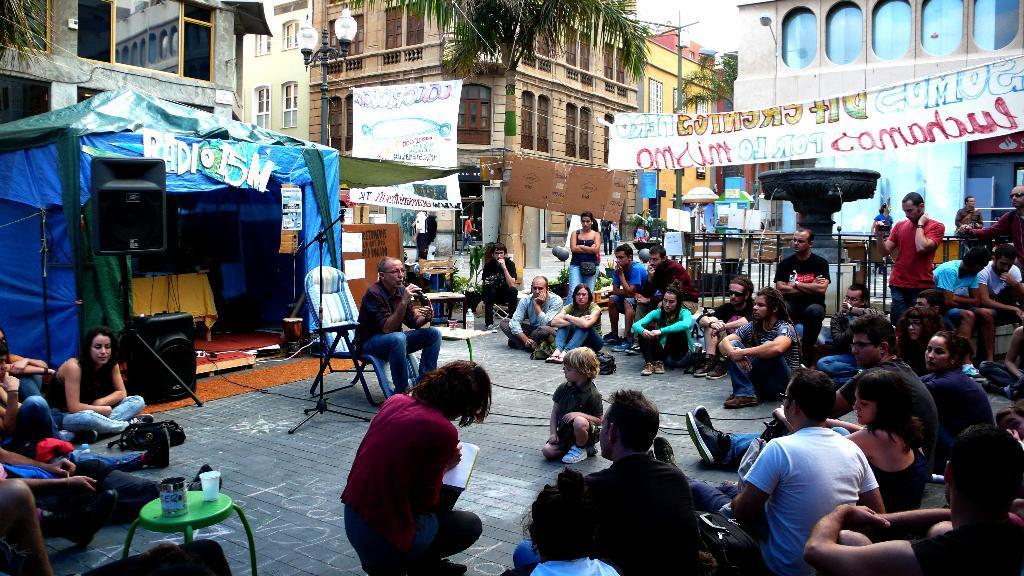Describe this image in one or two sentences. In the image there are many people sitting on the road, in the middle there is an old man sitting on chair and talking on mic, beside him there is a table with water bottle and glass on it and behind it there is a tent with speakers in front of it, this is clicked in a street, in the back there are buildings all over the image, there is a tree in middle of the road with banners on either side of it. 